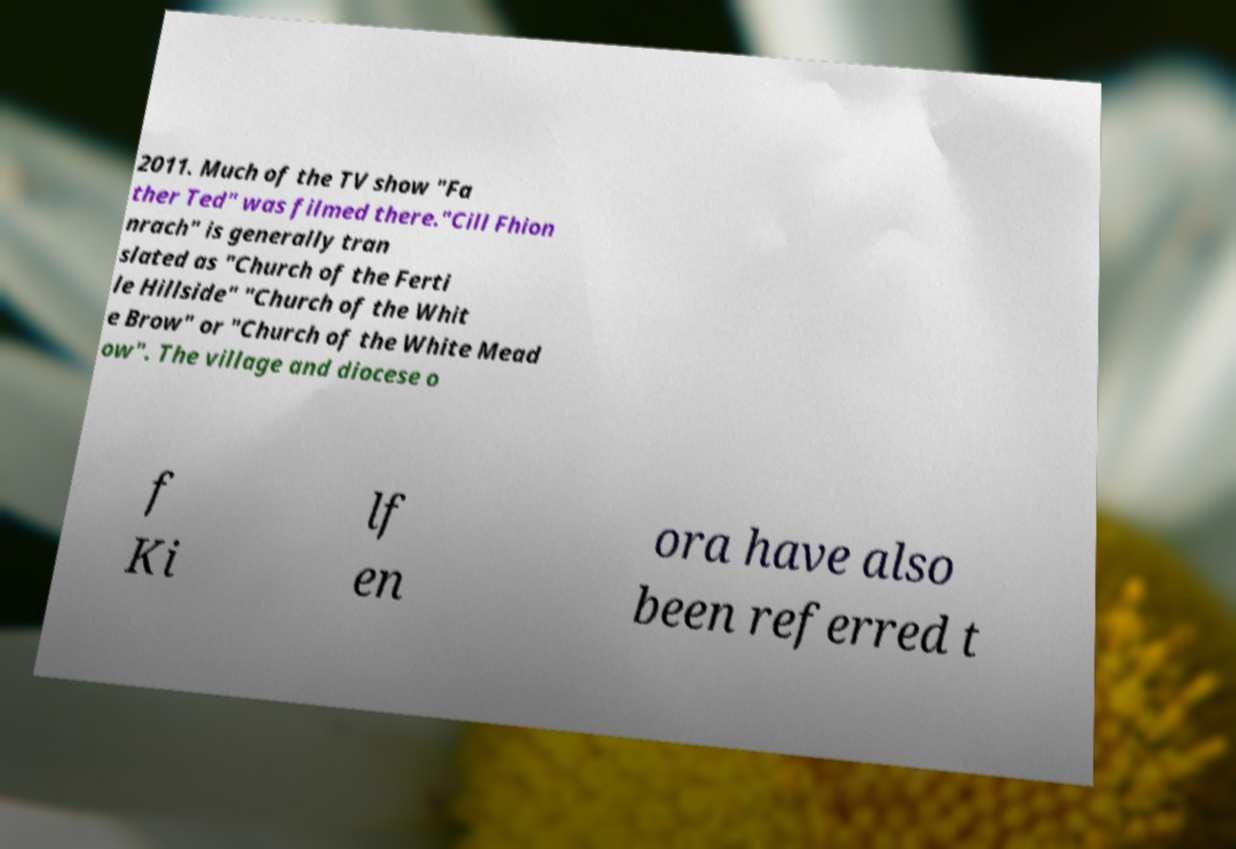There's text embedded in this image that I need extracted. Can you transcribe it verbatim? 2011. Much of the TV show "Fa ther Ted" was filmed there."Cill Fhion nrach" is generally tran slated as "Church of the Ferti le Hillside" "Church of the Whit e Brow" or "Church of the White Mead ow". The village and diocese o f Ki lf en ora have also been referred t 